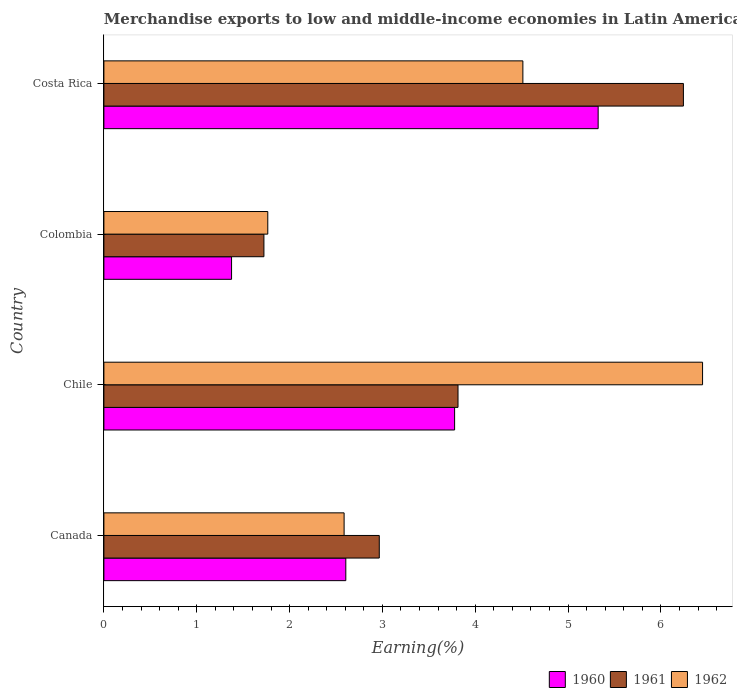Are the number of bars on each tick of the Y-axis equal?
Ensure brevity in your answer.  Yes. What is the percentage of amount earned from merchandise exports in 1960 in Colombia?
Offer a terse response. 1.38. Across all countries, what is the maximum percentage of amount earned from merchandise exports in 1961?
Keep it short and to the point. 6.24. Across all countries, what is the minimum percentage of amount earned from merchandise exports in 1961?
Ensure brevity in your answer.  1.72. In which country was the percentage of amount earned from merchandise exports in 1962 minimum?
Ensure brevity in your answer.  Colombia. What is the total percentage of amount earned from merchandise exports in 1960 in the graph?
Offer a very short reply. 13.08. What is the difference between the percentage of amount earned from merchandise exports in 1962 in Colombia and that in Costa Rica?
Ensure brevity in your answer.  -2.75. What is the difference between the percentage of amount earned from merchandise exports in 1960 in Canada and the percentage of amount earned from merchandise exports in 1961 in Colombia?
Your answer should be very brief. 0.88. What is the average percentage of amount earned from merchandise exports in 1961 per country?
Your answer should be compact. 3.69. What is the difference between the percentage of amount earned from merchandise exports in 1961 and percentage of amount earned from merchandise exports in 1960 in Chile?
Provide a succinct answer. 0.04. In how many countries, is the percentage of amount earned from merchandise exports in 1962 greater than 6.4 %?
Keep it short and to the point. 1. What is the ratio of the percentage of amount earned from merchandise exports in 1960 in Canada to that in Colombia?
Offer a terse response. 1.89. Is the difference between the percentage of amount earned from merchandise exports in 1961 in Chile and Colombia greater than the difference between the percentage of amount earned from merchandise exports in 1960 in Chile and Colombia?
Provide a succinct answer. No. What is the difference between the highest and the second highest percentage of amount earned from merchandise exports in 1962?
Keep it short and to the point. 1.94. What is the difference between the highest and the lowest percentage of amount earned from merchandise exports in 1962?
Make the answer very short. 4.68. Is the sum of the percentage of amount earned from merchandise exports in 1962 in Canada and Costa Rica greater than the maximum percentage of amount earned from merchandise exports in 1960 across all countries?
Provide a succinct answer. Yes. What does the 2nd bar from the bottom in Chile represents?
Offer a terse response. 1961. Are all the bars in the graph horizontal?
Give a very brief answer. Yes. What is the difference between two consecutive major ticks on the X-axis?
Keep it short and to the point. 1. Does the graph contain any zero values?
Ensure brevity in your answer.  No. Where does the legend appear in the graph?
Give a very brief answer. Bottom right. How many legend labels are there?
Your response must be concise. 3. What is the title of the graph?
Your response must be concise. Merchandise exports to low and middle-income economies in Latin America. Does "2000" appear as one of the legend labels in the graph?
Your answer should be compact. No. What is the label or title of the X-axis?
Your answer should be compact. Earning(%). What is the label or title of the Y-axis?
Give a very brief answer. Country. What is the Earning(%) in 1960 in Canada?
Offer a very short reply. 2.61. What is the Earning(%) of 1961 in Canada?
Your answer should be very brief. 2.97. What is the Earning(%) in 1962 in Canada?
Offer a very short reply. 2.59. What is the Earning(%) of 1960 in Chile?
Your response must be concise. 3.78. What is the Earning(%) in 1961 in Chile?
Offer a very short reply. 3.81. What is the Earning(%) of 1962 in Chile?
Provide a succinct answer. 6.45. What is the Earning(%) in 1960 in Colombia?
Offer a very short reply. 1.38. What is the Earning(%) of 1961 in Colombia?
Ensure brevity in your answer.  1.72. What is the Earning(%) of 1962 in Colombia?
Provide a short and direct response. 1.77. What is the Earning(%) of 1960 in Costa Rica?
Give a very brief answer. 5.32. What is the Earning(%) of 1961 in Costa Rica?
Your answer should be very brief. 6.24. What is the Earning(%) of 1962 in Costa Rica?
Your answer should be very brief. 4.51. Across all countries, what is the maximum Earning(%) in 1960?
Give a very brief answer. 5.32. Across all countries, what is the maximum Earning(%) in 1961?
Make the answer very short. 6.24. Across all countries, what is the maximum Earning(%) in 1962?
Make the answer very short. 6.45. Across all countries, what is the minimum Earning(%) in 1960?
Give a very brief answer. 1.38. Across all countries, what is the minimum Earning(%) of 1961?
Offer a very short reply. 1.72. Across all countries, what is the minimum Earning(%) in 1962?
Your answer should be very brief. 1.77. What is the total Earning(%) of 1960 in the graph?
Your answer should be compact. 13.08. What is the total Earning(%) in 1961 in the graph?
Make the answer very short. 14.75. What is the total Earning(%) in 1962 in the graph?
Make the answer very short. 15.31. What is the difference between the Earning(%) of 1960 in Canada and that in Chile?
Your answer should be very brief. -1.17. What is the difference between the Earning(%) of 1961 in Canada and that in Chile?
Keep it short and to the point. -0.85. What is the difference between the Earning(%) of 1962 in Canada and that in Chile?
Provide a succinct answer. -3.86. What is the difference between the Earning(%) of 1960 in Canada and that in Colombia?
Your answer should be very brief. 1.23. What is the difference between the Earning(%) of 1961 in Canada and that in Colombia?
Provide a succinct answer. 1.24. What is the difference between the Earning(%) of 1962 in Canada and that in Colombia?
Offer a very short reply. 0.82. What is the difference between the Earning(%) in 1960 in Canada and that in Costa Rica?
Give a very brief answer. -2.72. What is the difference between the Earning(%) in 1961 in Canada and that in Costa Rica?
Your answer should be compact. -3.28. What is the difference between the Earning(%) of 1962 in Canada and that in Costa Rica?
Your answer should be very brief. -1.93. What is the difference between the Earning(%) in 1960 in Chile and that in Colombia?
Your answer should be very brief. 2.4. What is the difference between the Earning(%) in 1961 in Chile and that in Colombia?
Make the answer very short. 2.09. What is the difference between the Earning(%) in 1962 in Chile and that in Colombia?
Offer a terse response. 4.68. What is the difference between the Earning(%) of 1960 in Chile and that in Costa Rica?
Offer a terse response. -1.55. What is the difference between the Earning(%) of 1961 in Chile and that in Costa Rica?
Provide a succinct answer. -2.43. What is the difference between the Earning(%) of 1962 in Chile and that in Costa Rica?
Give a very brief answer. 1.94. What is the difference between the Earning(%) in 1960 in Colombia and that in Costa Rica?
Your response must be concise. -3.95. What is the difference between the Earning(%) in 1961 in Colombia and that in Costa Rica?
Make the answer very short. -4.52. What is the difference between the Earning(%) in 1962 in Colombia and that in Costa Rica?
Offer a very short reply. -2.75. What is the difference between the Earning(%) of 1960 in Canada and the Earning(%) of 1961 in Chile?
Your answer should be compact. -1.21. What is the difference between the Earning(%) in 1960 in Canada and the Earning(%) in 1962 in Chile?
Keep it short and to the point. -3.84. What is the difference between the Earning(%) in 1961 in Canada and the Earning(%) in 1962 in Chile?
Provide a succinct answer. -3.48. What is the difference between the Earning(%) of 1960 in Canada and the Earning(%) of 1961 in Colombia?
Offer a terse response. 0.88. What is the difference between the Earning(%) of 1960 in Canada and the Earning(%) of 1962 in Colombia?
Your answer should be compact. 0.84. What is the difference between the Earning(%) in 1961 in Canada and the Earning(%) in 1962 in Colombia?
Provide a short and direct response. 1.2. What is the difference between the Earning(%) of 1960 in Canada and the Earning(%) of 1961 in Costa Rica?
Your answer should be compact. -3.64. What is the difference between the Earning(%) in 1960 in Canada and the Earning(%) in 1962 in Costa Rica?
Provide a succinct answer. -1.91. What is the difference between the Earning(%) in 1961 in Canada and the Earning(%) in 1962 in Costa Rica?
Your answer should be compact. -1.55. What is the difference between the Earning(%) of 1960 in Chile and the Earning(%) of 1961 in Colombia?
Keep it short and to the point. 2.05. What is the difference between the Earning(%) in 1960 in Chile and the Earning(%) in 1962 in Colombia?
Give a very brief answer. 2.01. What is the difference between the Earning(%) of 1961 in Chile and the Earning(%) of 1962 in Colombia?
Give a very brief answer. 2.05. What is the difference between the Earning(%) in 1960 in Chile and the Earning(%) in 1961 in Costa Rica?
Your answer should be very brief. -2.46. What is the difference between the Earning(%) in 1960 in Chile and the Earning(%) in 1962 in Costa Rica?
Offer a terse response. -0.74. What is the difference between the Earning(%) of 1961 in Chile and the Earning(%) of 1962 in Costa Rica?
Ensure brevity in your answer.  -0.7. What is the difference between the Earning(%) in 1960 in Colombia and the Earning(%) in 1961 in Costa Rica?
Your answer should be very brief. -4.87. What is the difference between the Earning(%) in 1960 in Colombia and the Earning(%) in 1962 in Costa Rica?
Keep it short and to the point. -3.14. What is the difference between the Earning(%) of 1961 in Colombia and the Earning(%) of 1962 in Costa Rica?
Offer a terse response. -2.79. What is the average Earning(%) in 1960 per country?
Provide a short and direct response. 3.27. What is the average Earning(%) in 1961 per country?
Ensure brevity in your answer.  3.69. What is the average Earning(%) in 1962 per country?
Your answer should be very brief. 3.83. What is the difference between the Earning(%) in 1960 and Earning(%) in 1961 in Canada?
Keep it short and to the point. -0.36. What is the difference between the Earning(%) of 1960 and Earning(%) of 1962 in Canada?
Offer a very short reply. 0.02. What is the difference between the Earning(%) of 1961 and Earning(%) of 1962 in Canada?
Your response must be concise. 0.38. What is the difference between the Earning(%) of 1960 and Earning(%) of 1961 in Chile?
Your response must be concise. -0.04. What is the difference between the Earning(%) in 1960 and Earning(%) in 1962 in Chile?
Give a very brief answer. -2.67. What is the difference between the Earning(%) of 1961 and Earning(%) of 1962 in Chile?
Ensure brevity in your answer.  -2.63. What is the difference between the Earning(%) of 1960 and Earning(%) of 1961 in Colombia?
Offer a terse response. -0.35. What is the difference between the Earning(%) in 1960 and Earning(%) in 1962 in Colombia?
Offer a very short reply. -0.39. What is the difference between the Earning(%) of 1961 and Earning(%) of 1962 in Colombia?
Provide a short and direct response. -0.04. What is the difference between the Earning(%) in 1960 and Earning(%) in 1961 in Costa Rica?
Offer a very short reply. -0.92. What is the difference between the Earning(%) of 1960 and Earning(%) of 1962 in Costa Rica?
Provide a succinct answer. 0.81. What is the difference between the Earning(%) in 1961 and Earning(%) in 1962 in Costa Rica?
Keep it short and to the point. 1.73. What is the ratio of the Earning(%) in 1960 in Canada to that in Chile?
Your answer should be compact. 0.69. What is the ratio of the Earning(%) of 1961 in Canada to that in Chile?
Provide a succinct answer. 0.78. What is the ratio of the Earning(%) in 1962 in Canada to that in Chile?
Offer a terse response. 0.4. What is the ratio of the Earning(%) in 1960 in Canada to that in Colombia?
Offer a very short reply. 1.89. What is the ratio of the Earning(%) in 1961 in Canada to that in Colombia?
Your answer should be compact. 1.72. What is the ratio of the Earning(%) of 1962 in Canada to that in Colombia?
Keep it short and to the point. 1.47. What is the ratio of the Earning(%) of 1960 in Canada to that in Costa Rica?
Your response must be concise. 0.49. What is the ratio of the Earning(%) in 1961 in Canada to that in Costa Rica?
Provide a short and direct response. 0.48. What is the ratio of the Earning(%) in 1962 in Canada to that in Costa Rica?
Provide a short and direct response. 0.57. What is the ratio of the Earning(%) in 1960 in Chile to that in Colombia?
Ensure brevity in your answer.  2.75. What is the ratio of the Earning(%) in 1961 in Chile to that in Colombia?
Keep it short and to the point. 2.21. What is the ratio of the Earning(%) in 1962 in Chile to that in Colombia?
Offer a terse response. 3.65. What is the ratio of the Earning(%) of 1960 in Chile to that in Costa Rica?
Offer a very short reply. 0.71. What is the ratio of the Earning(%) of 1961 in Chile to that in Costa Rica?
Provide a succinct answer. 0.61. What is the ratio of the Earning(%) in 1962 in Chile to that in Costa Rica?
Keep it short and to the point. 1.43. What is the ratio of the Earning(%) of 1960 in Colombia to that in Costa Rica?
Keep it short and to the point. 0.26. What is the ratio of the Earning(%) in 1961 in Colombia to that in Costa Rica?
Your answer should be very brief. 0.28. What is the ratio of the Earning(%) of 1962 in Colombia to that in Costa Rica?
Your response must be concise. 0.39. What is the difference between the highest and the second highest Earning(%) in 1960?
Your response must be concise. 1.55. What is the difference between the highest and the second highest Earning(%) in 1961?
Give a very brief answer. 2.43. What is the difference between the highest and the second highest Earning(%) in 1962?
Ensure brevity in your answer.  1.94. What is the difference between the highest and the lowest Earning(%) of 1960?
Make the answer very short. 3.95. What is the difference between the highest and the lowest Earning(%) of 1961?
Your response must be concise. 4.52. What is the difference between the highest and the lowest Earning(%) in 1962?
Your response must be concise. 4.68. 